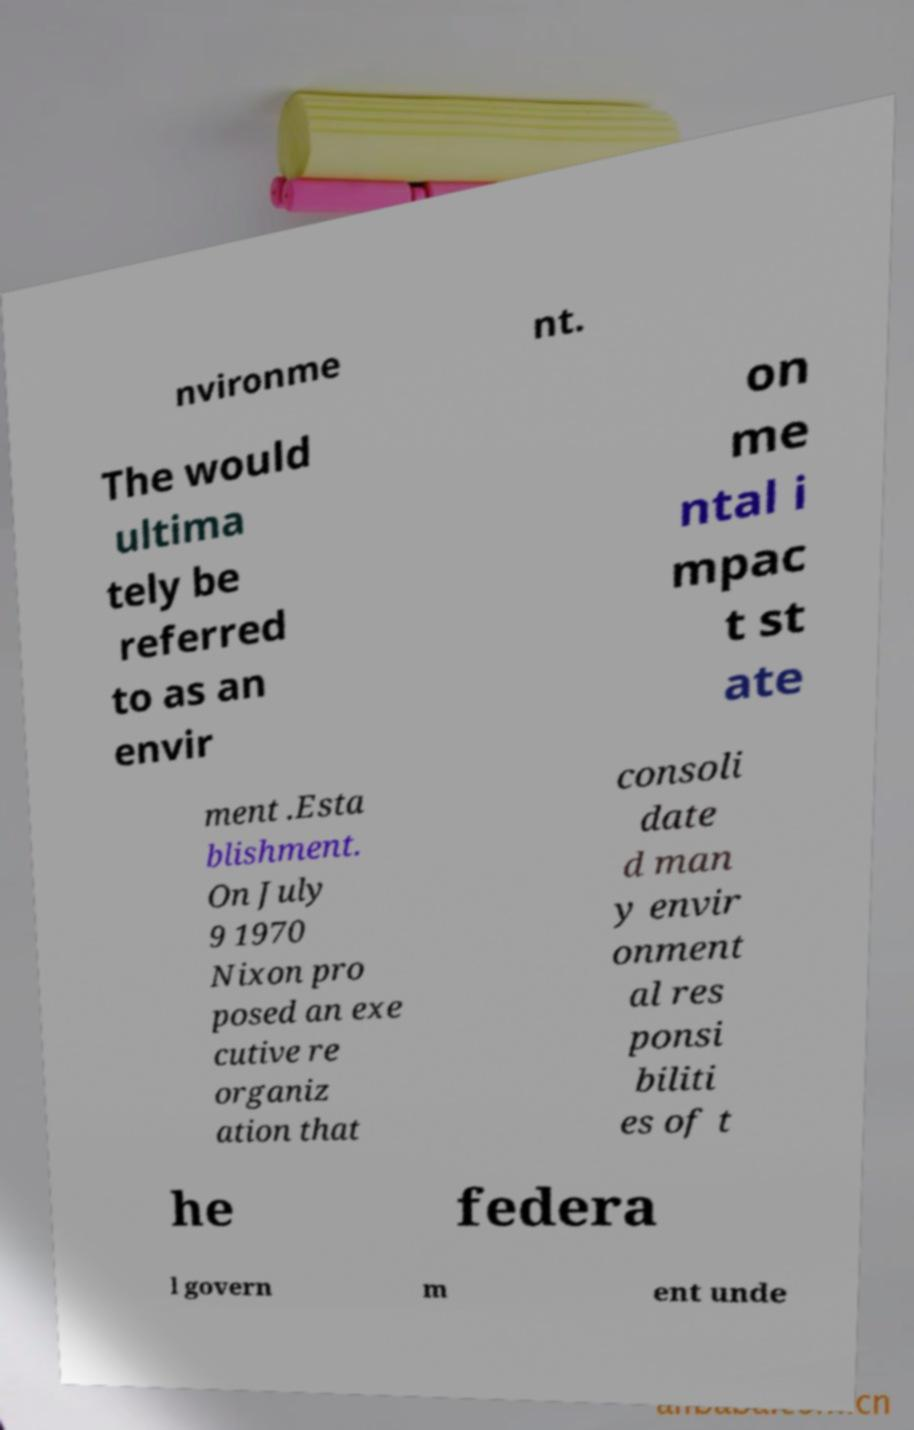Please identify and transcribe the text found in this image. nvironme nt. The would ultima tely be referred to as an envir on me ntal i mpac t st ate ment .Esta blishment. On July 9 1970 Nixon pro posed an exe cutive re organiz ation that consoli date d man y envir onment al res ponsi biliti es of t he federa l govern m ent unde 